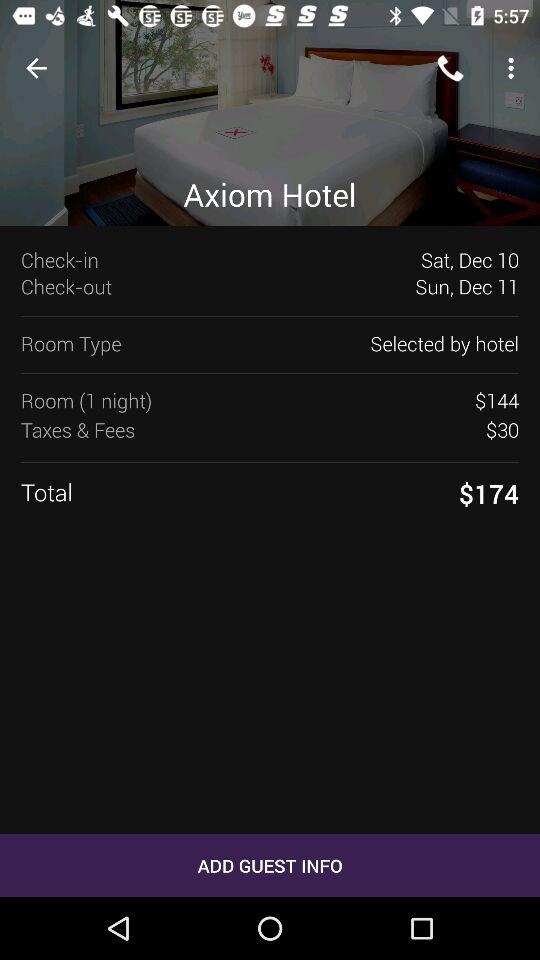What is the name of the hotel? The name of the hotel is "Axiom Hotel". 